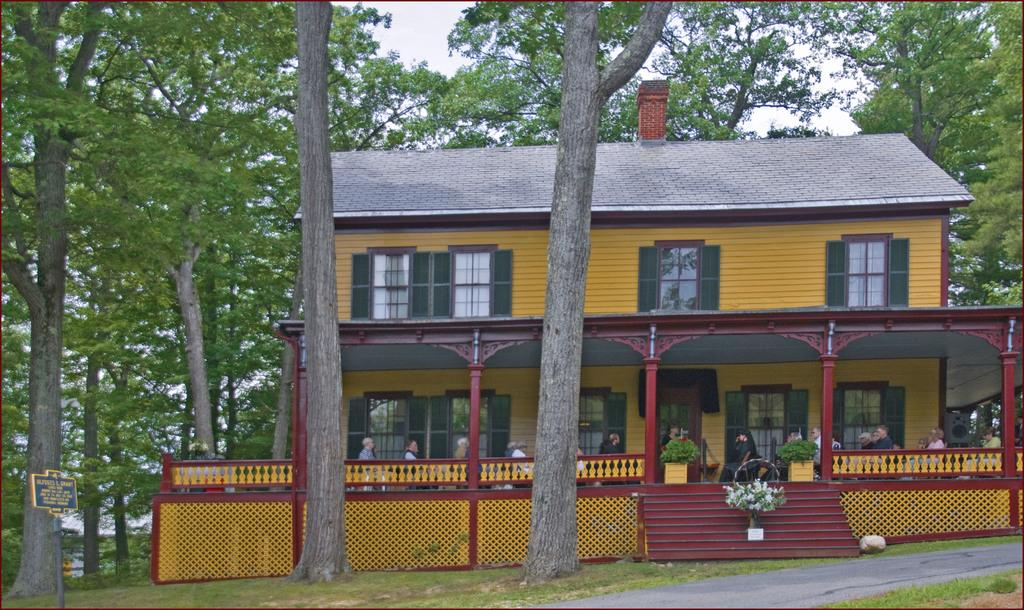What type of structure is visible in the image? There is a building in the image. What features can be observed on the building? The building has windows. What type of vegetation is present in the image? There are trees in the image. What architectural feature is visible in the image? There are stairs in the image. What objects are used for planting in the image? Flower pots are present in the image. Who or what is visible in the image? There are people in the image. What part of the natural environment is visible in the image? The sky is visible in the image. What is attached to a pole in the image? There is a board attached to a pole in the image. What type of stew is being prepared by the giants in the image? There are no giants present in the image, and therefore no stew preparation can be observed. What is the desire of the people in the image? The image does not provide information about the desires of the people present. 